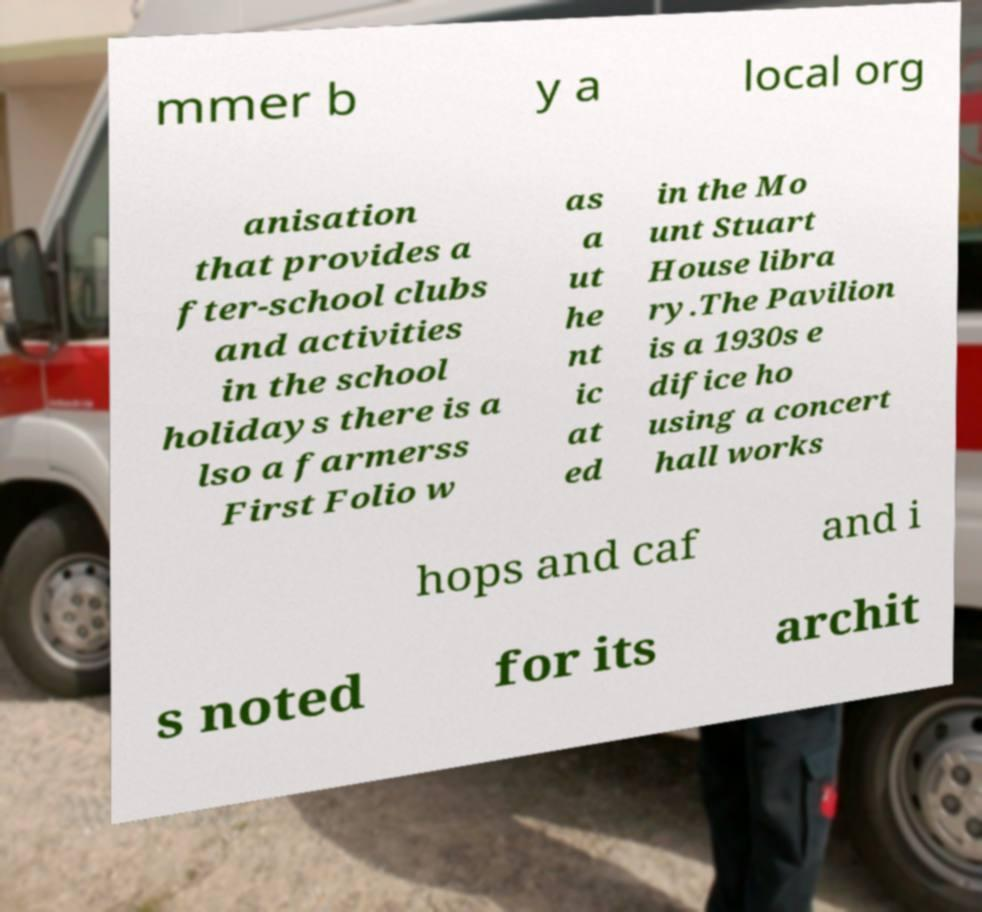What messages or text are displayed in this image? I need them in a readable, typed format. mmer b y a local org anisation that provides a fter-school clubs and activities in the school holidays there is a lso a farmerss First Folio w as a ut he nt ic at ed in the Mo unt Stuart House libra ry.The Pavilion is a 1930s e difice ho using a concert hall works hops and caf and i s noted for its archit 